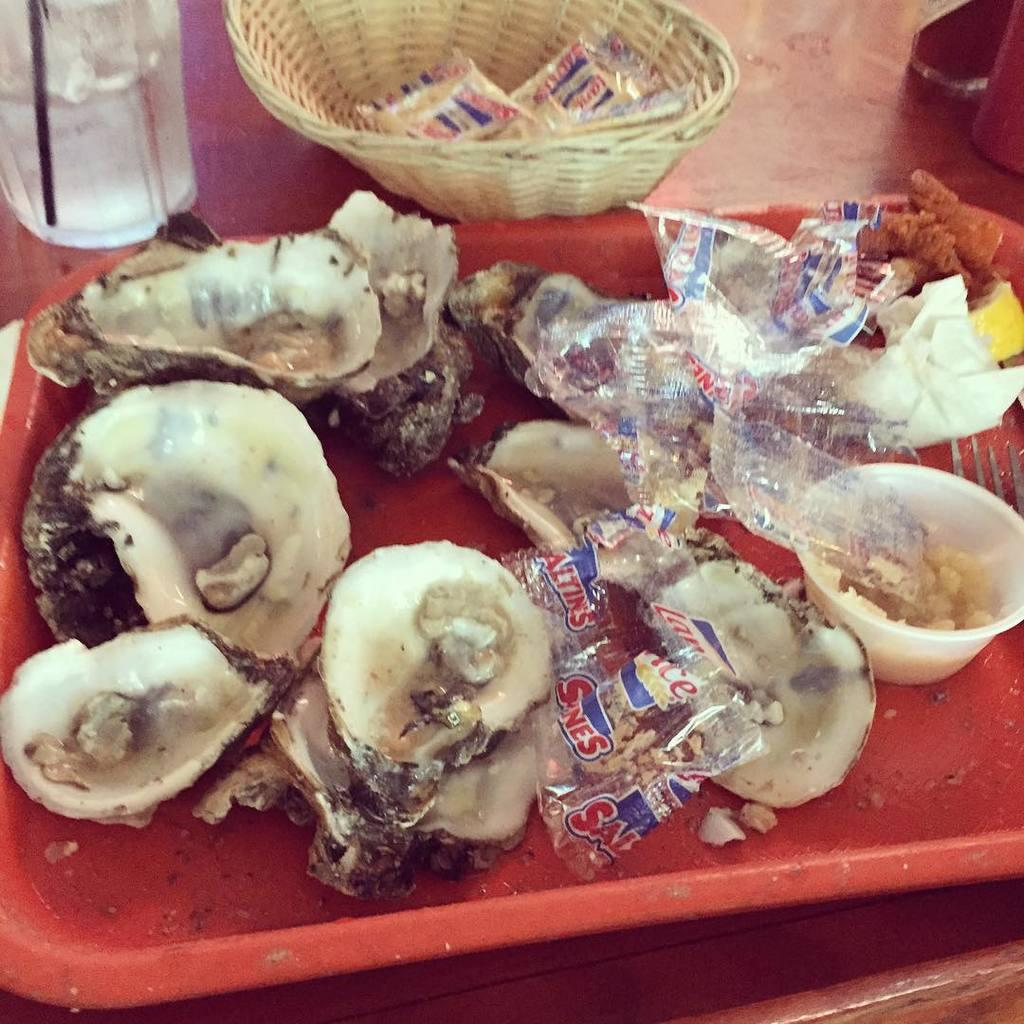What can be seen on the surface in the image? There are objects on the surface in the image. Can you describe any specific items among the objects? There is a plate with food items among the objects. Where is the key hidden in the image? There is no key present in the image. What type of love is being expressed in the image? There is no indication of love or any emotional expression in the image. 